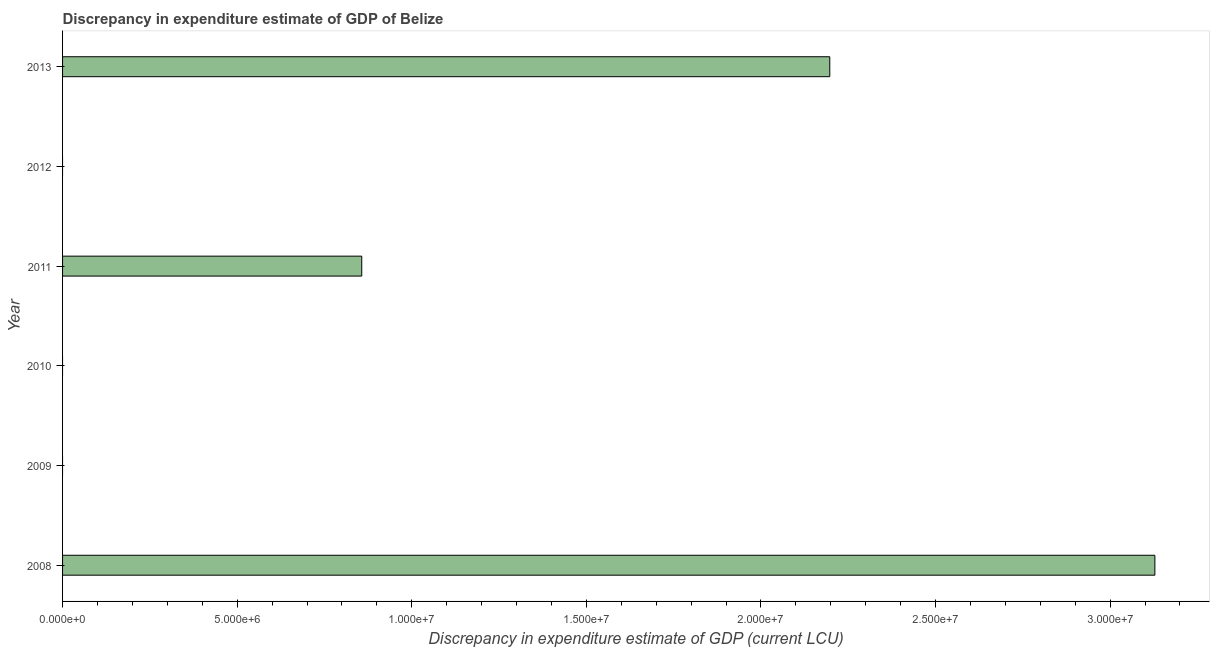What is the title of the graph?
Keep it short and to the point. Discrepancy in expenditure estimate of GDP of Belize. What is the label or title of the X-axis?
Make the answer very short. Discrepancy in expenditure estimate of GDP (current LCU). What is the label or title of the Y-axis?
Provide a succinct answer. Year. What is the discrepancy in expenditure estimate of gdp in 2013?
Your answer should be compact. 2.20e+07. Across all years, what is the maximum discrepancy in expenditure estimate of gdp?
Give a very brief answer. 3.13e+07. What is the sum of the discrepancy in expenditure estimate of gdp?
Ensure brevity in your answer.  6.18e+07. What is the difference between the discrepancy in expenditure estimate of gdp in 2011 and 2013?
Offer a very short reply. -1.34e+07. What is the average discrepancy in expenditure estimate of gdp per year?
Offer a very short reply. 1.03e+07. What is the median discrepancy in expenditure estimate of gdp?
Give a very brief answer. 4.28e+06. What is the ratio of the discrepancy in expenditure estimate of gdp in 2008 to that in 2011?
Offer a terse response. 3.65. Is the discrepancy in expenditure estimate of gdp in 2011 less than that in 2013?
Your answer should be compact. Yes. Is the difference between the discrepancy in expenditure estimate of gdp in 2008 and 2011 greater than the difference between any two years?
Your answer should be compact. No. What is the difference between the highest and the second highest discrepancy in expenditure estimate of gdp?
Offer a very short reply. 9.31e+06. What is the difference between the highest and the lowest discrepancy in expenditure estimate of gdp?
Provide a short and direct response. 3.13e+07. Are all the bars in the graph horizontal?
Your response must be concise. Yes. What is the difference between two consecutive major ticks on the X-axis?
Your answer should be very brief. 5.00e+06. Are the values on the major ticks of X-axis written in scientific E-notation?
Give a very brief answer. Yes. What is the Discrepancy in expenditure estimate of GDP (current LCU) in 2008?
Provide a short and direct response. 3.13e+07. What is the Discrepancy in expenditure estimate of GDP (current LCU) in 2009?
Your answer should be compact. 0. What is the Discrepancy in expenditure estimate of GDP (current LCU) of 2010?
Make the answer very short. 0. What is the Discrepancy in expenditure estimate of GDP (current LCU) of 2011?
Ensure brevity in your answer.  8.57e+06. What is the Discrepancy in expenditure estimate of GDP (current LCU) of 2012?
Your answer should be compact. 0. What is the Discrepancy in expenditure estimate of GDP (current LCU) of 2013?
Provide a succinct answer. 2.20e+07. What is the difference between the Discrepancy in expenditure estimate of GDP (current LCU) in 2008 and 2011?
Make the answer very short. 2.27e+07. What is the difference between the Discrepancy in expenditure estimate of GDP (current LCU) in 2008 and 2013?
Offer a terse response. 9.31e+06. What is the difference between the Discrepancy in expenditure estimate of GDP (current LCU) in 2011 and 2013?
Your answer should be compact. -1.34e+07. What is the ratio of the Discrepancy in expenditure estimate of GDP (current LCU) in 2008 to that in 2011?
Your answer should be compact. 3.65. What is the ratio of the Discrepancy in expenditure estimate of GDP (current LCU) in 2008 to that in 2013?
Your answer should be compact. 1.42. What is the ratio of the Discrepancy in expenditure estimate of GDP (current LCU) in 2011 to that in 2013?
Your answer should be compact. 0.39. 